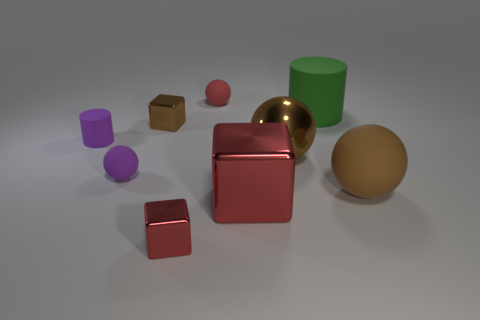Subtract 1 balls. How many balls are left? 3 Add 1 big brown shiny things. How many objects exist? 10 Subtract all cylinders. How many objects are left? 7 Add 2 red matte things. How many red matte things exist? 3 Subtract 0 gray cylinders. How many objects are left? 9 Subtract all large brown blocks. Subtract all small purple matte spheres. How many objects are left? 8 Add 4 spheres. How many spheres are left? 8 